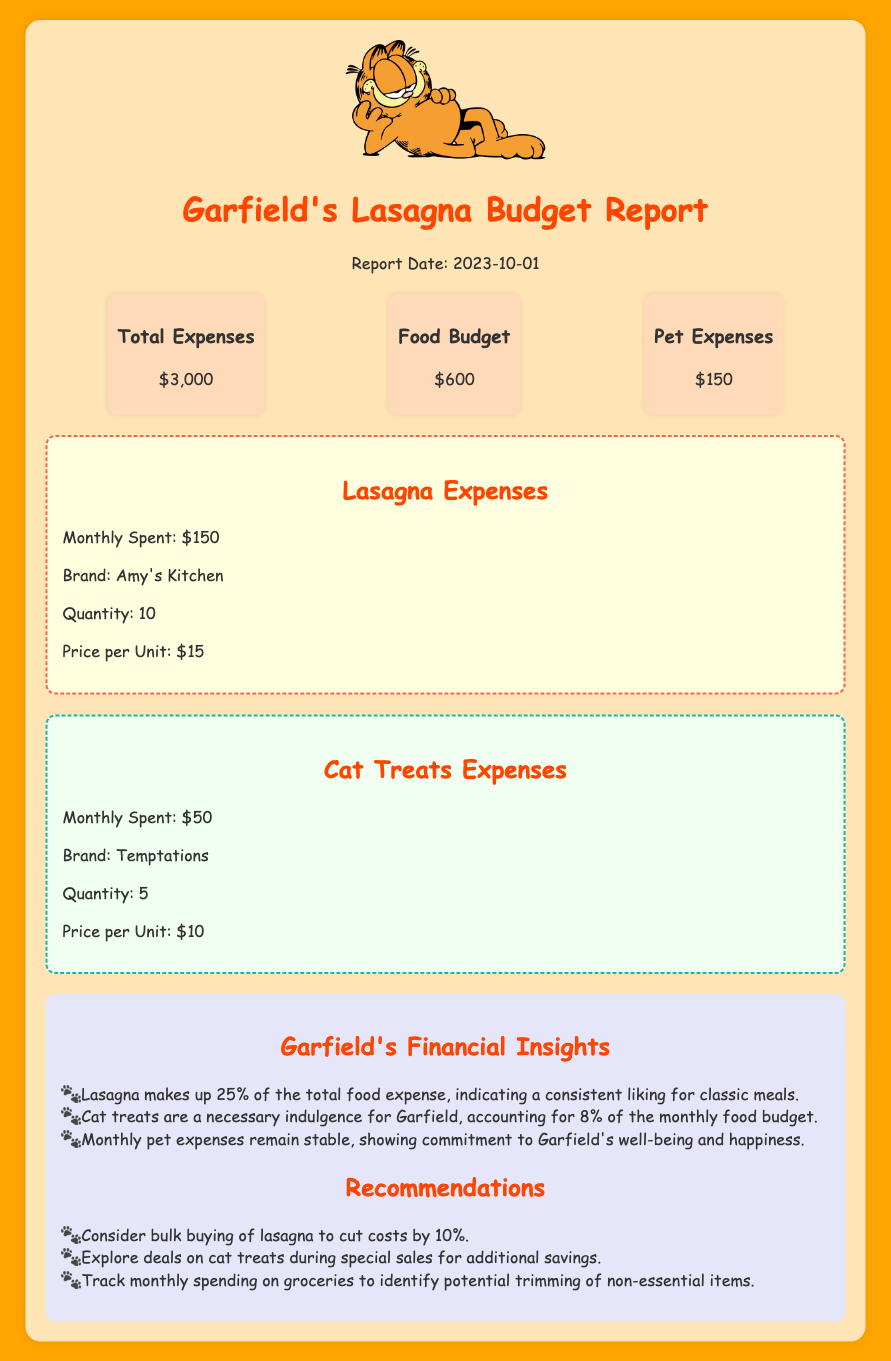what is the report date? The report date is stated at the top of the document, indicating when the budget report was created.
Answer: 2023-10-01 what is the total expense amount? The total expense amount is highlighted in the expense overview section of the document.
Answer: $3,000 how much was spent on lasagna? The lasagna expenses are detailed in a specific section, showing the monthly amount spent.
Answer: $150 what brand of cat treats is mentioned? The brand of cat treats is specified under the cat treats expenses section of the report.
Answer: Temptations what percentage of the food budget is spent on lasagna? The document states that lasagna makes up a certain portion of the total food expense in the insights section.
Answer: 25% how many units of lasagna were purchased? The quantity of lasagna purchased is shown in the lasagna expenses section.
Answer: 10 what is the total budget allocated for food? The food budget is presented in the expense overview section of the document.
Answer: $600 which category accounts for 8% of the monthly food budget? The insights section specifies that a certain item accounts for 8% of the monthly food budget.
Answer: Cat treats what recommendation is made regarding lasagna purchases? The recommendations section advises on how to manage lasagna expenses effectively.
Answer: Consider bulk buying to cut costs by 10% 